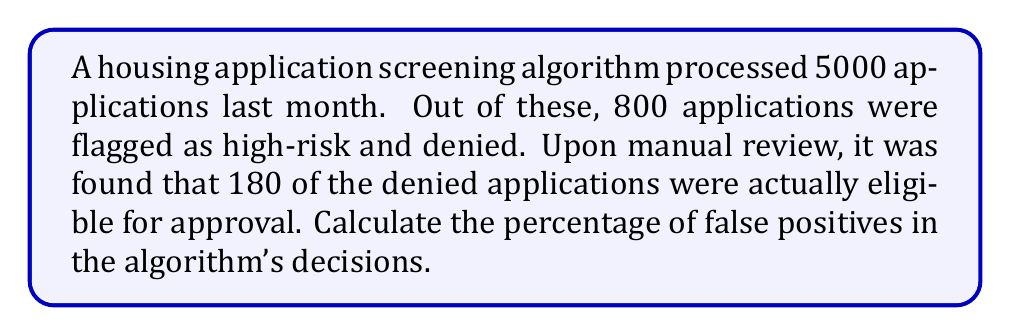Could you help me with this problem? To solve this problem, we need to follow these steps:

1. Identify the total number of denied applications:
   Total denied = 800

2. Identify the number of false positives:
   False positives are the applications that were wrongly denied.
   False positives = 180

3. Calculate the percentage of false positives:
   To calculate the percentage, we use the formula:
   $$ \text{Percentage} = \frac{\text{Number of false positives}}{\text{Total number of denied applications}} \times 100\% $$

   Substituting the values:
   $$ \text{Percentage of false positives} = \frac{180}{800} \times 100\% $$

4. Simplify the fraction:
   $$ \frac{180}{800} = \frac{9}{40} = 0.225 $$

5. Calculate the final percentage:
   $$ 0.225 \times 100\% = 22.5\% $$

Therefore, the percentage of false positives in the algorithm's decisions is 22.5%.
Answer: 22.5% 